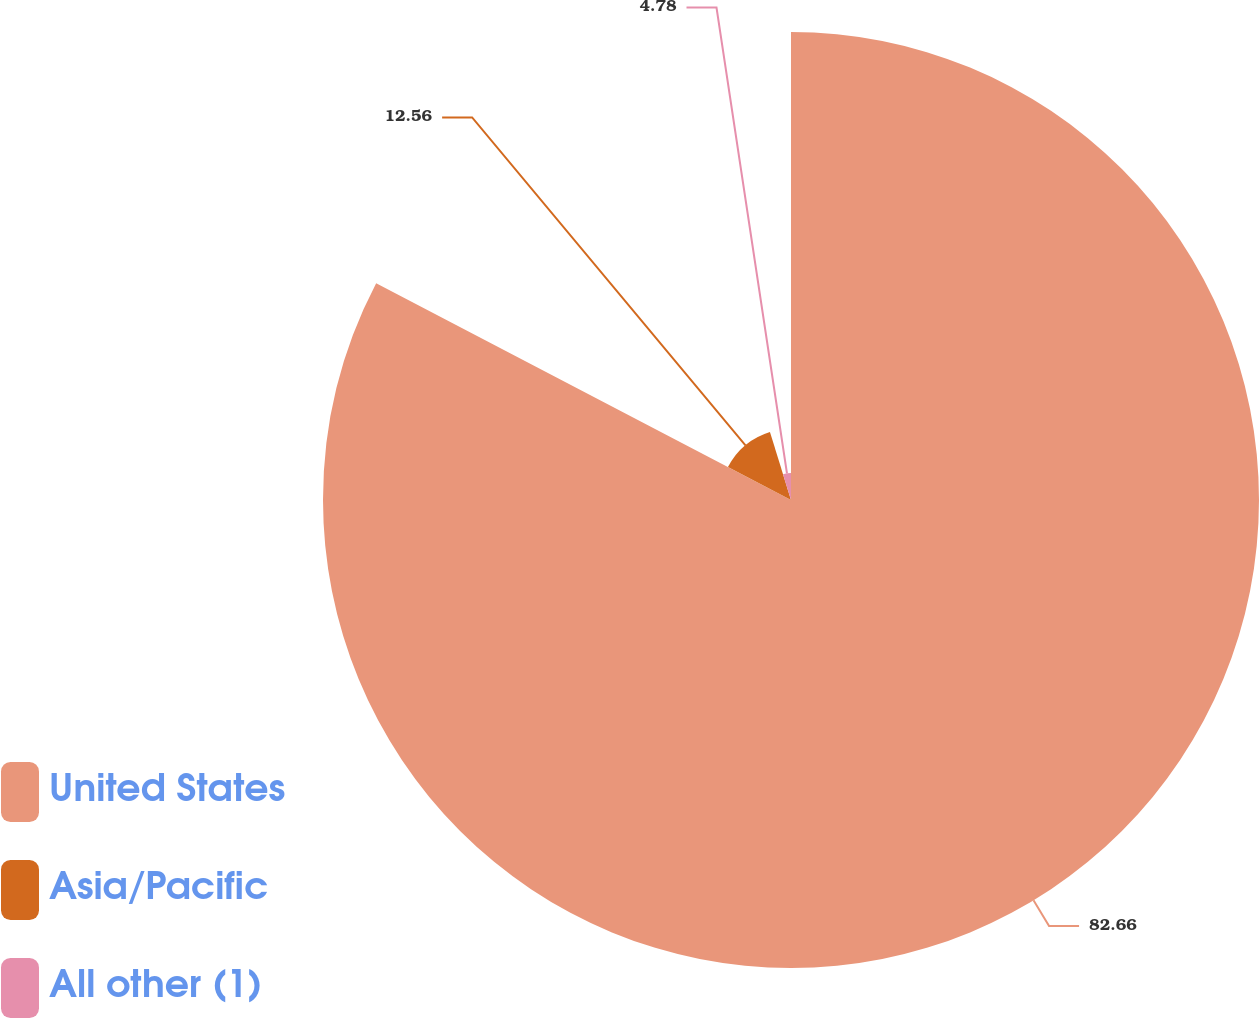Convert chart to OTSL. <chart><loc_0><loc_0><loc_500><loc_500><pie_chart><fcel>United States<fcel>Asia/Pacific<fcel>All other (1)<nl><fcel>82.66%<fcel>12.56%<fcel>4.78%<nl></chart> 